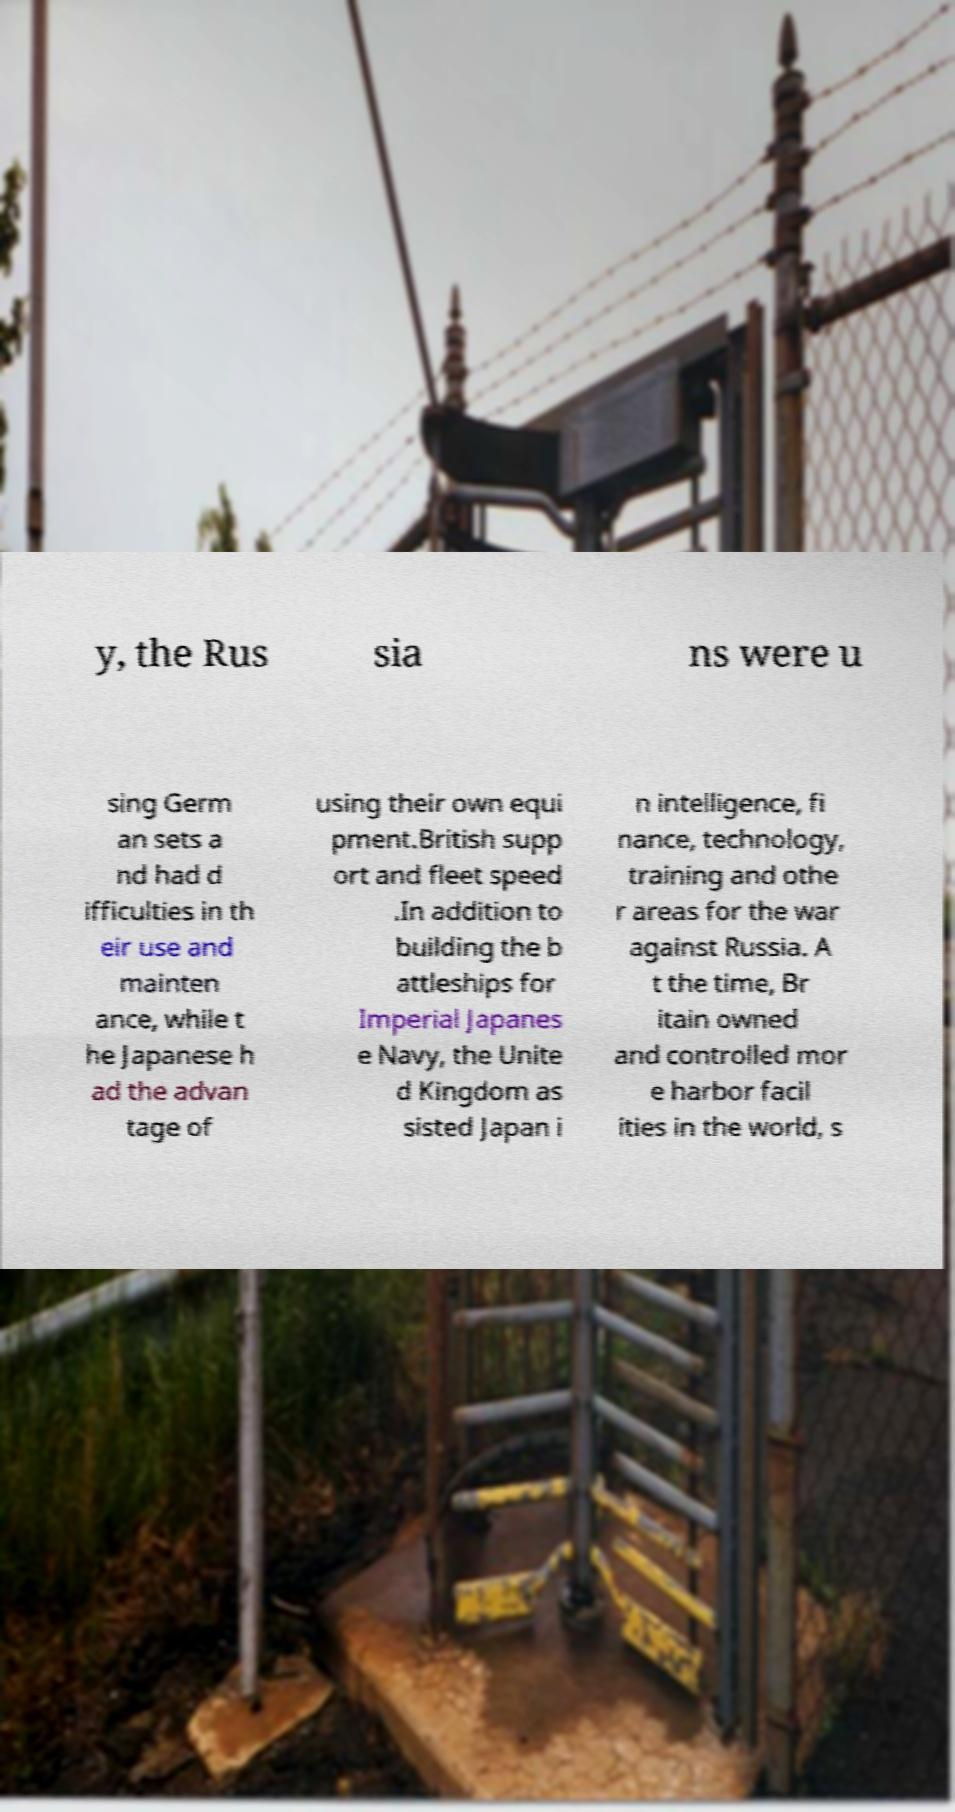There's text embedded in this image that I need extracted. Can you transcribe it verbatim? y, the Rus sia ns were u sing Germ an sets a nd had d ifficulties in th eir use and mainten ance, while t he Japanese h ad the advan tage of using their own equi pment.British supp ort and fleet speed .In addition to building the b attleships for Imperial Japanes e Navy, the Unite d Kingdom as sisted Japan i n intelligence, fi nance, technology, training and othe r areas for the war against Russia. A t the time, Br itain owned and controlled mor e harbor facil ities in the world, s 